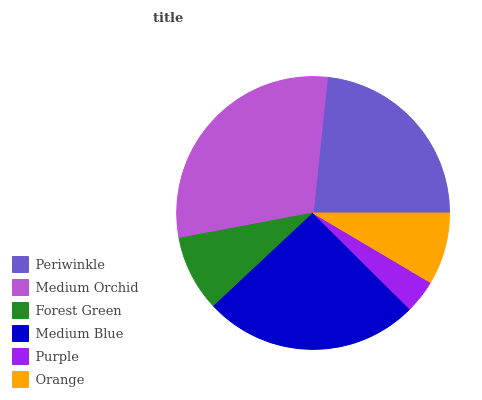Is Purple the minimum?
Answer yes or no. Yes. Is Medium Orchid the maximum?
Answer yes or no. Yes. Is Forest Green the minimum?
Answer yes or no. No. Is Forest Green the maximum?
Answer yes or no. No. Is Medium Orchid greater than Forest Green?
Answer yes or no. Yes. Is Forest Green less than Medium Orchid?
Answer yes or no. Yes. Is Forest Green greater than Medium Orchid?
Answer yes or no. No. Is Medium Orchid less than Forest Green?
Answer yes or no. No. Is Periwinkle the high median?
Answer yes or no. Yes. Is Forest Green the low median?
Answer yes or no. Yes. Is Forest Green the high median?
Answer yes or no. No. Is Medium Orchid the low median?
Answer yes or no. No. 